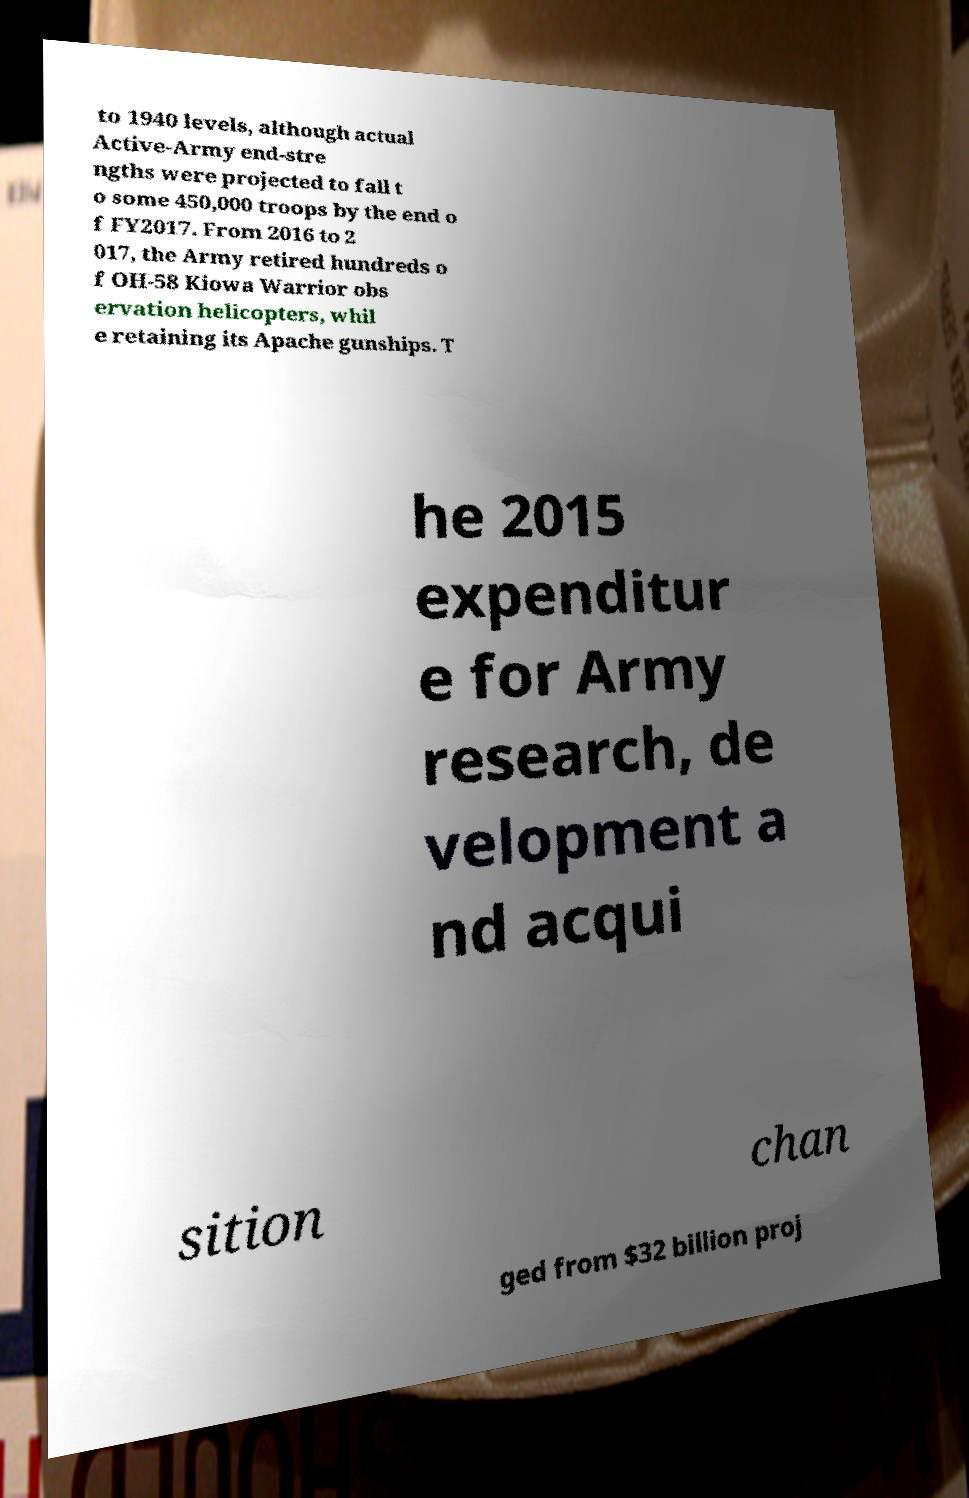Can you accurately transcribe the text from the provided image for me? to 1940 levels, although actual Active-Army end-stre ngths were projected to fall t o some 450,000 troops by the end o f FY2017. From 2016 to 2 017, the Army retired hundreds o f OH-58 Kiowa Warrior obs ervation helicopters, whil e retaining its Apache gunships. T he 2015 expenditur e for Army research, de velopment a nd acqui sition chan ged from $32 billion proj 